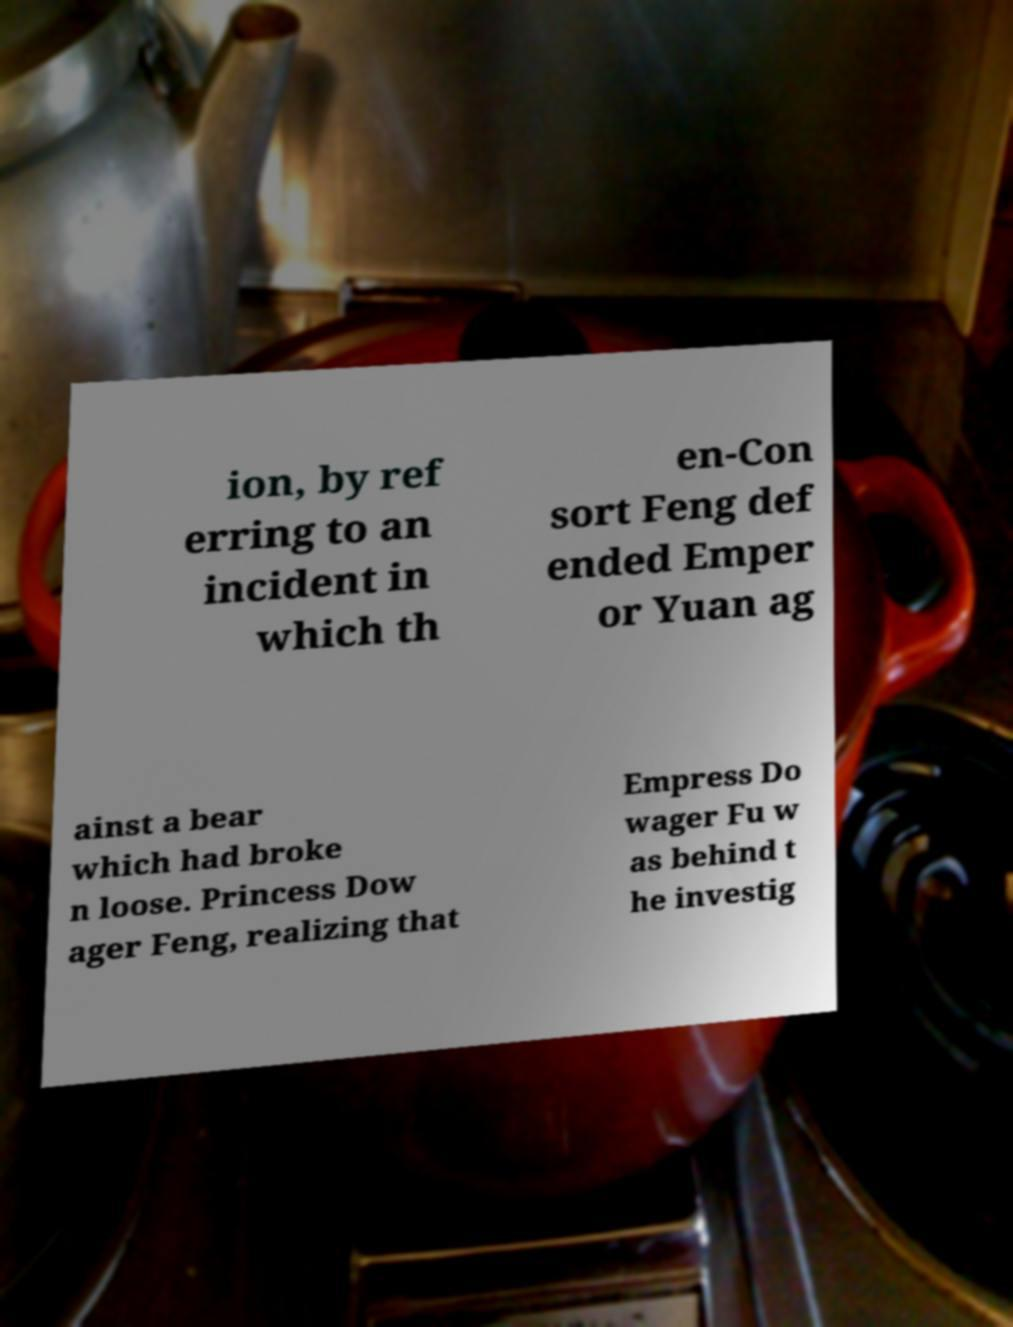There's text embedded in this image that I need extracted. Can you transcribe it verbatim? ion, by ref erring to an incident in which th en-Con sort Feng def ended Emper or Yuan ag ainst a bear which had broke n loose. Princess Dow ager Feng, realizing that Empress Do wager Fu w as behind t he investig 